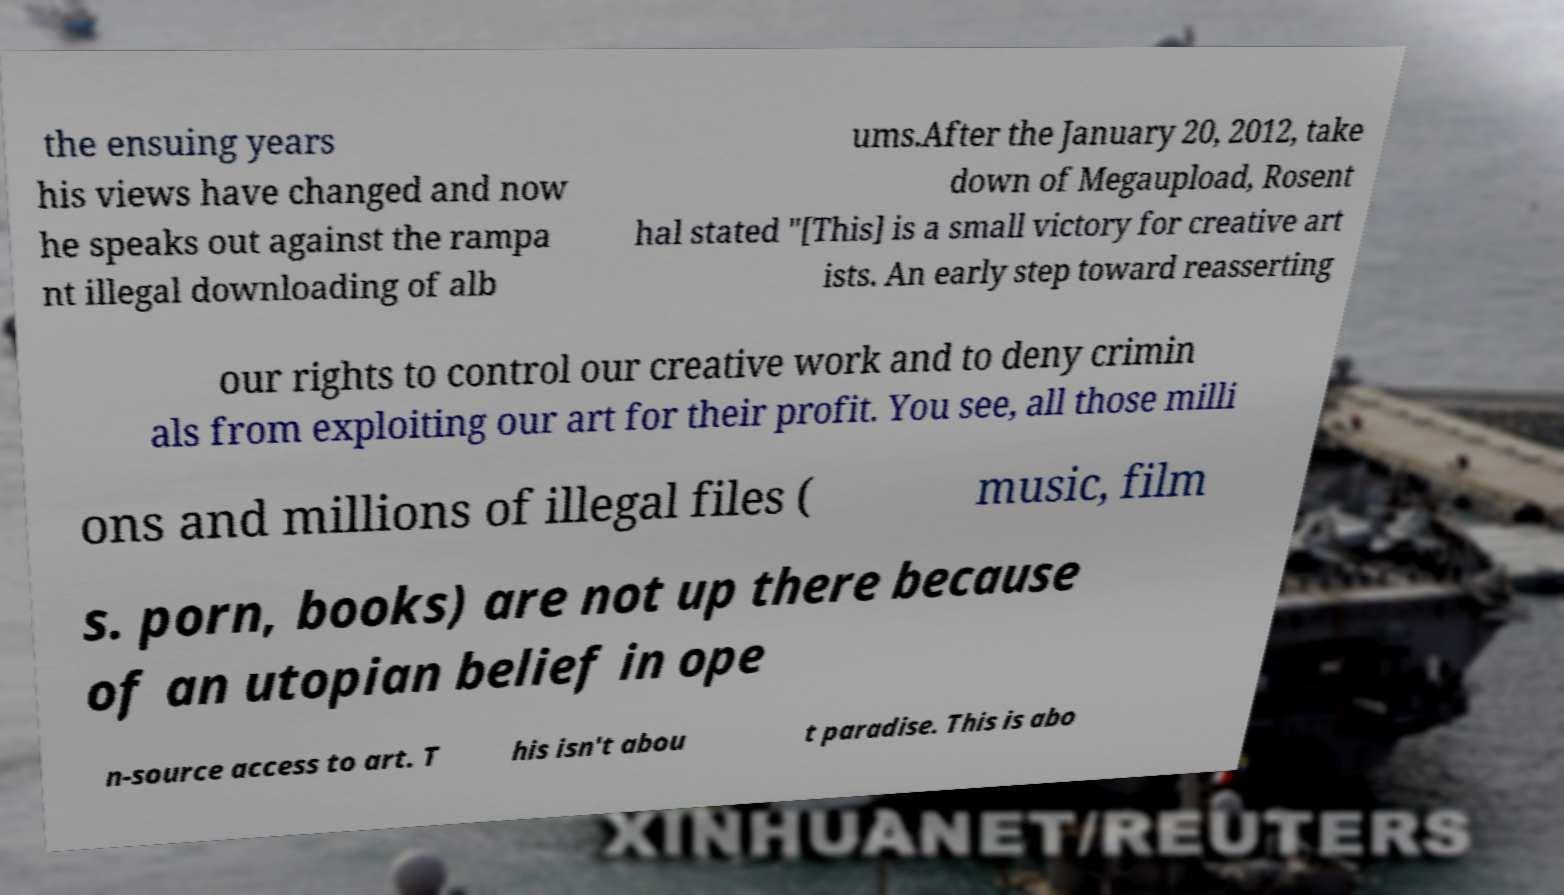Can you read and provide the text displayed in the image?This photo seems to have some interesting text. Can you extract and type it out for me? the ensuing years his views have changed and now he speaks out against the rampa nt illegal downloading of alb ums.After the January 20, 2012, take down of Megaupload, Rosent hal stated "[This] is a small victory for creative art ists. An early step toward reasserting our rights to control our creative work and to deny crimin als from exploiting our art for their profit. You see, all those milli ons and millions of illegal files ( music, film s. porn, books) are not up there because of an utopian belief in ope n-source access to art. T his isn't abou t paradise. This is abo 